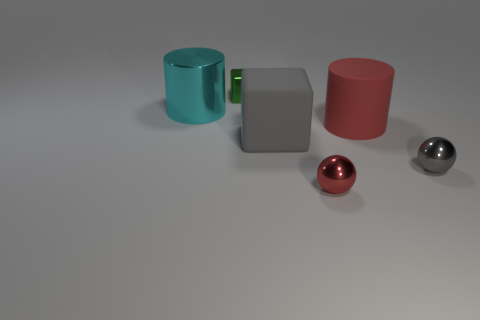Add 1 large brown shiny blocks. How many objects exist? 7 Subtract all cylinders. How many objects are left? 4 Subtract all red matte things. Subtract all tiny green matte balls. How many objects are left? 5 Add 1 green objects. How many green objects are left? 2 Add 4 green metal things. How many green metal things exist? 5 Subtract 0 yellow spheres. How many objects are left? 6 